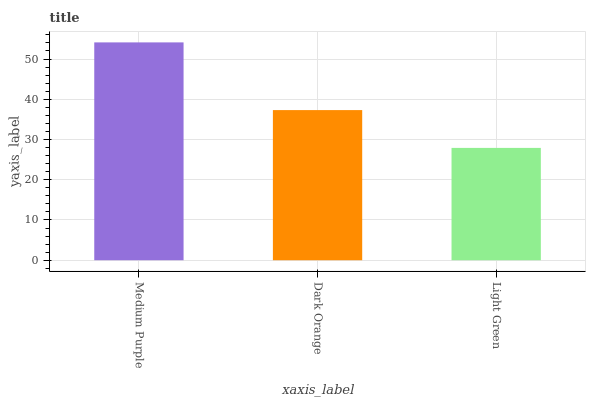Is Light Green the minimum?
Answer yes or no. Yes. Is Medium Purple the maximum?
Answer yes or no. Yes. Is Dark Orange the minimum?
Answer yes or no. No. Is Dark Orange the maximum?
Answer yes or no. No. Is Medium Purple greater than Dark Orange?
Answer yes or no. Yes. Is Dark Orange less than Medium Purple?
Answer yes or no. Yes. Is Dark Orange greater than Medium Purple?
Answer yes or no. No. Is Medium Purple less than Dark Orange?
Answer yes or no. No. Is Dark Orange the high median?
Answer yes or no. Yes. Is Dark Orange the low median?
Answer yes or no. Yes. Is Light Green the high median?
Answer yes or no. No. Is Light Green the low median?
Answer yes or no. No. 